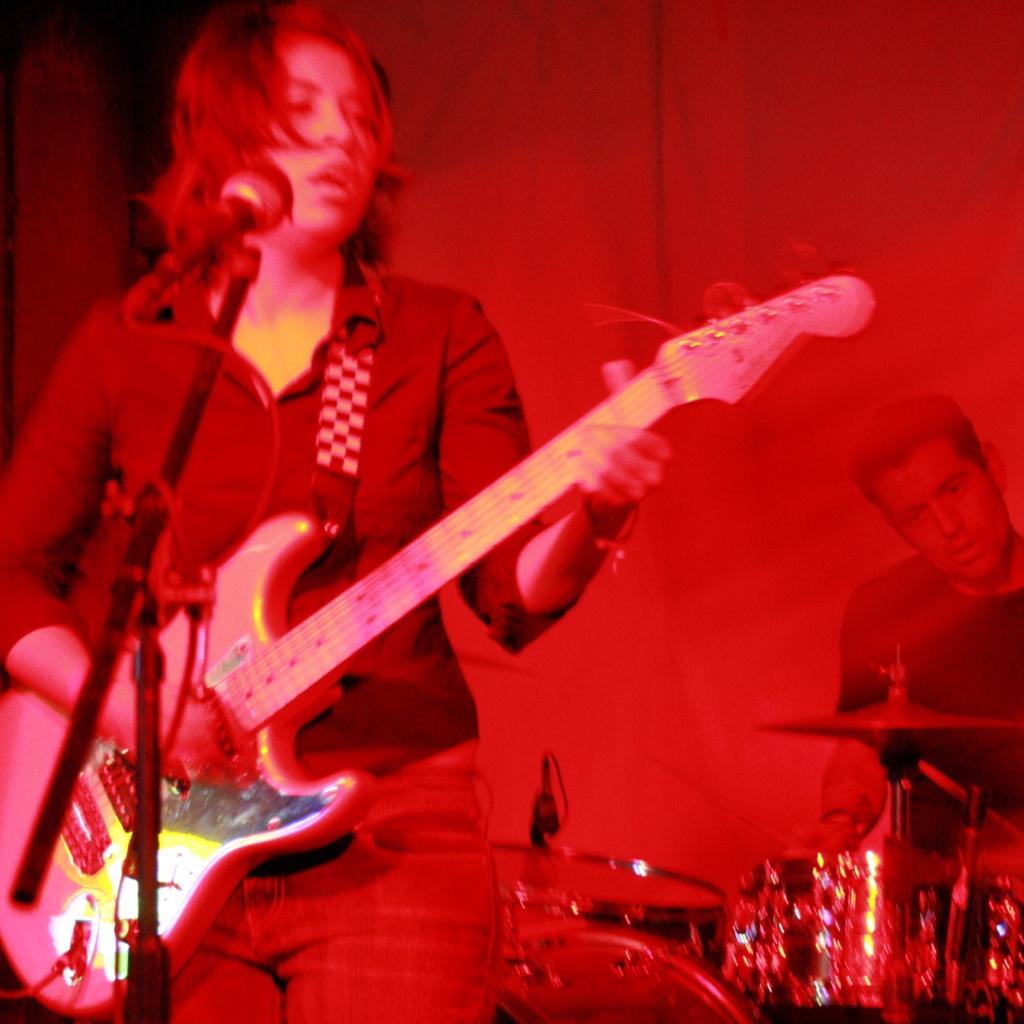How would you summarize this image in a sentence or two? In this picture a lady is playing a guitar and also singing with a mic placed in front of her. In the background we observe a guy playing drums and there are many musical instruments in the picture. The picture is red in color. 